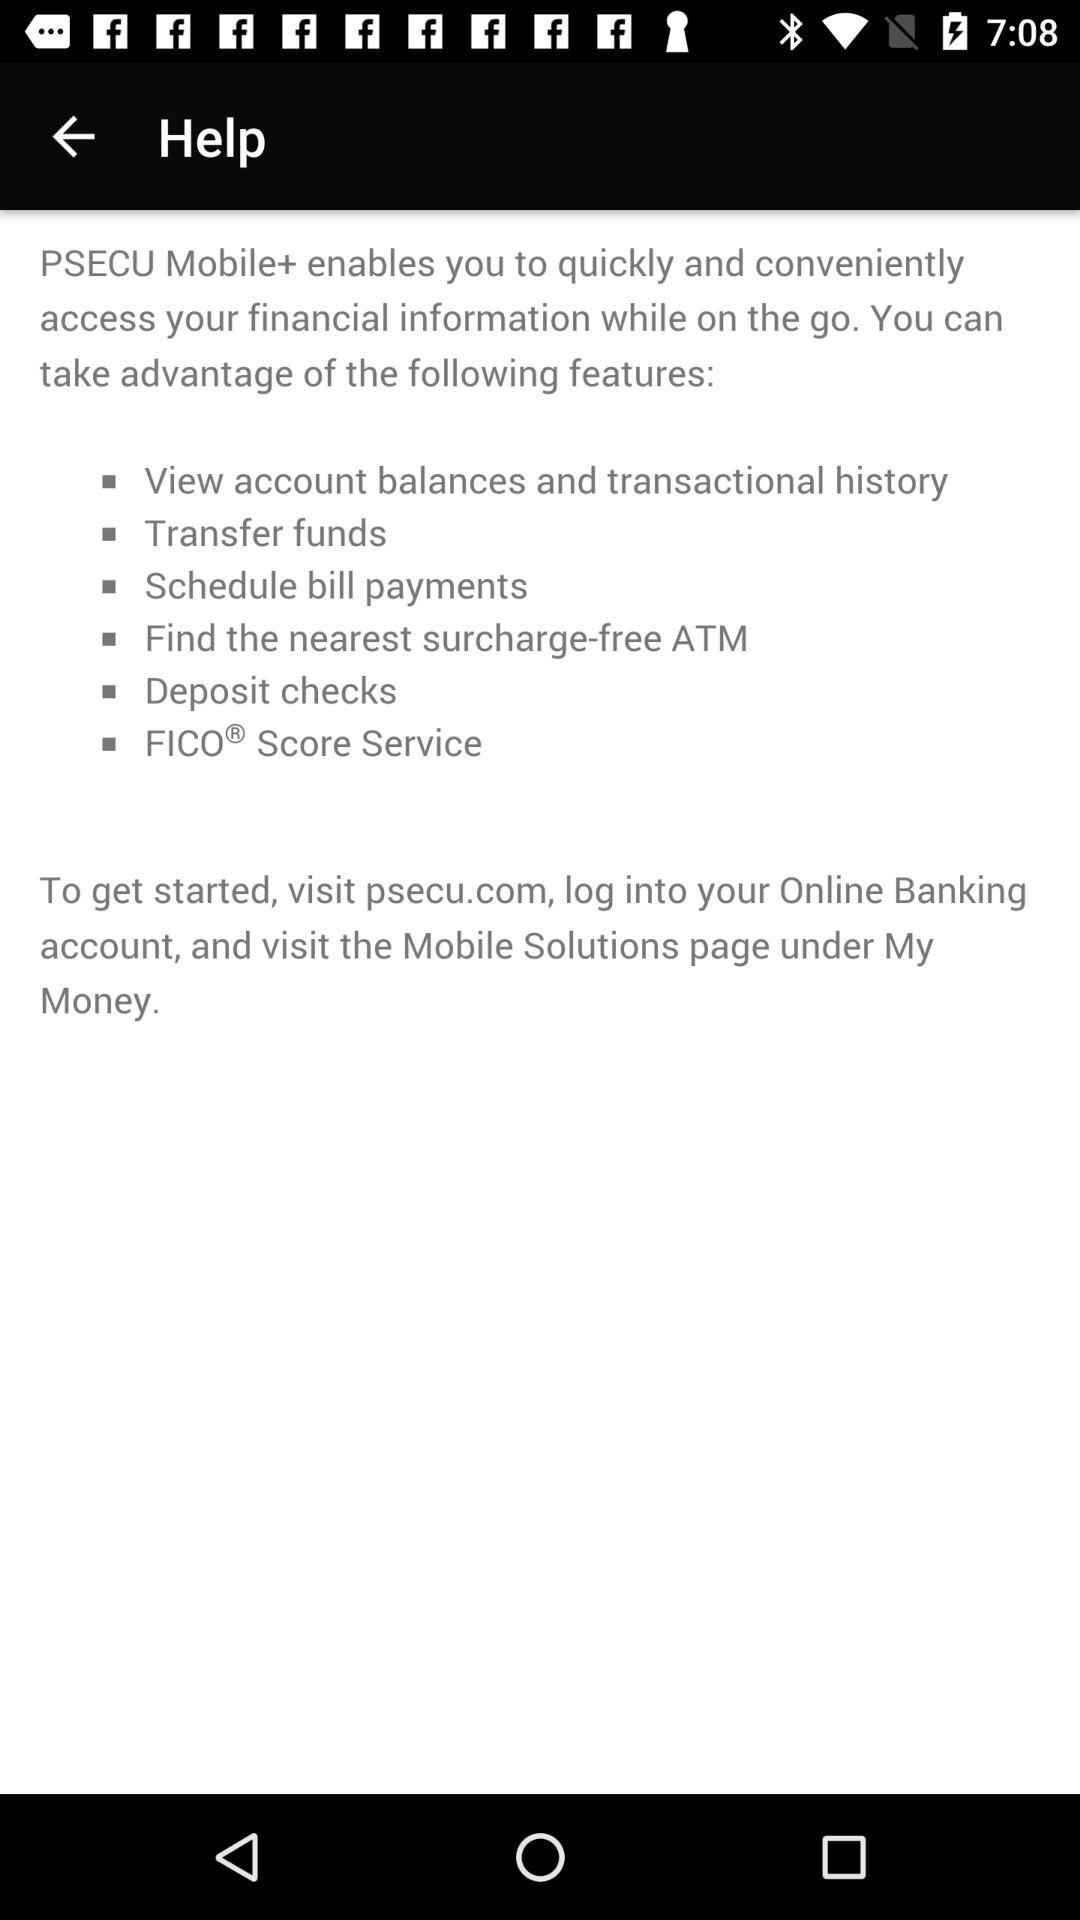How many features does PSECU Mobile+ offer?
Answer the question using a single word or phrase. 6 